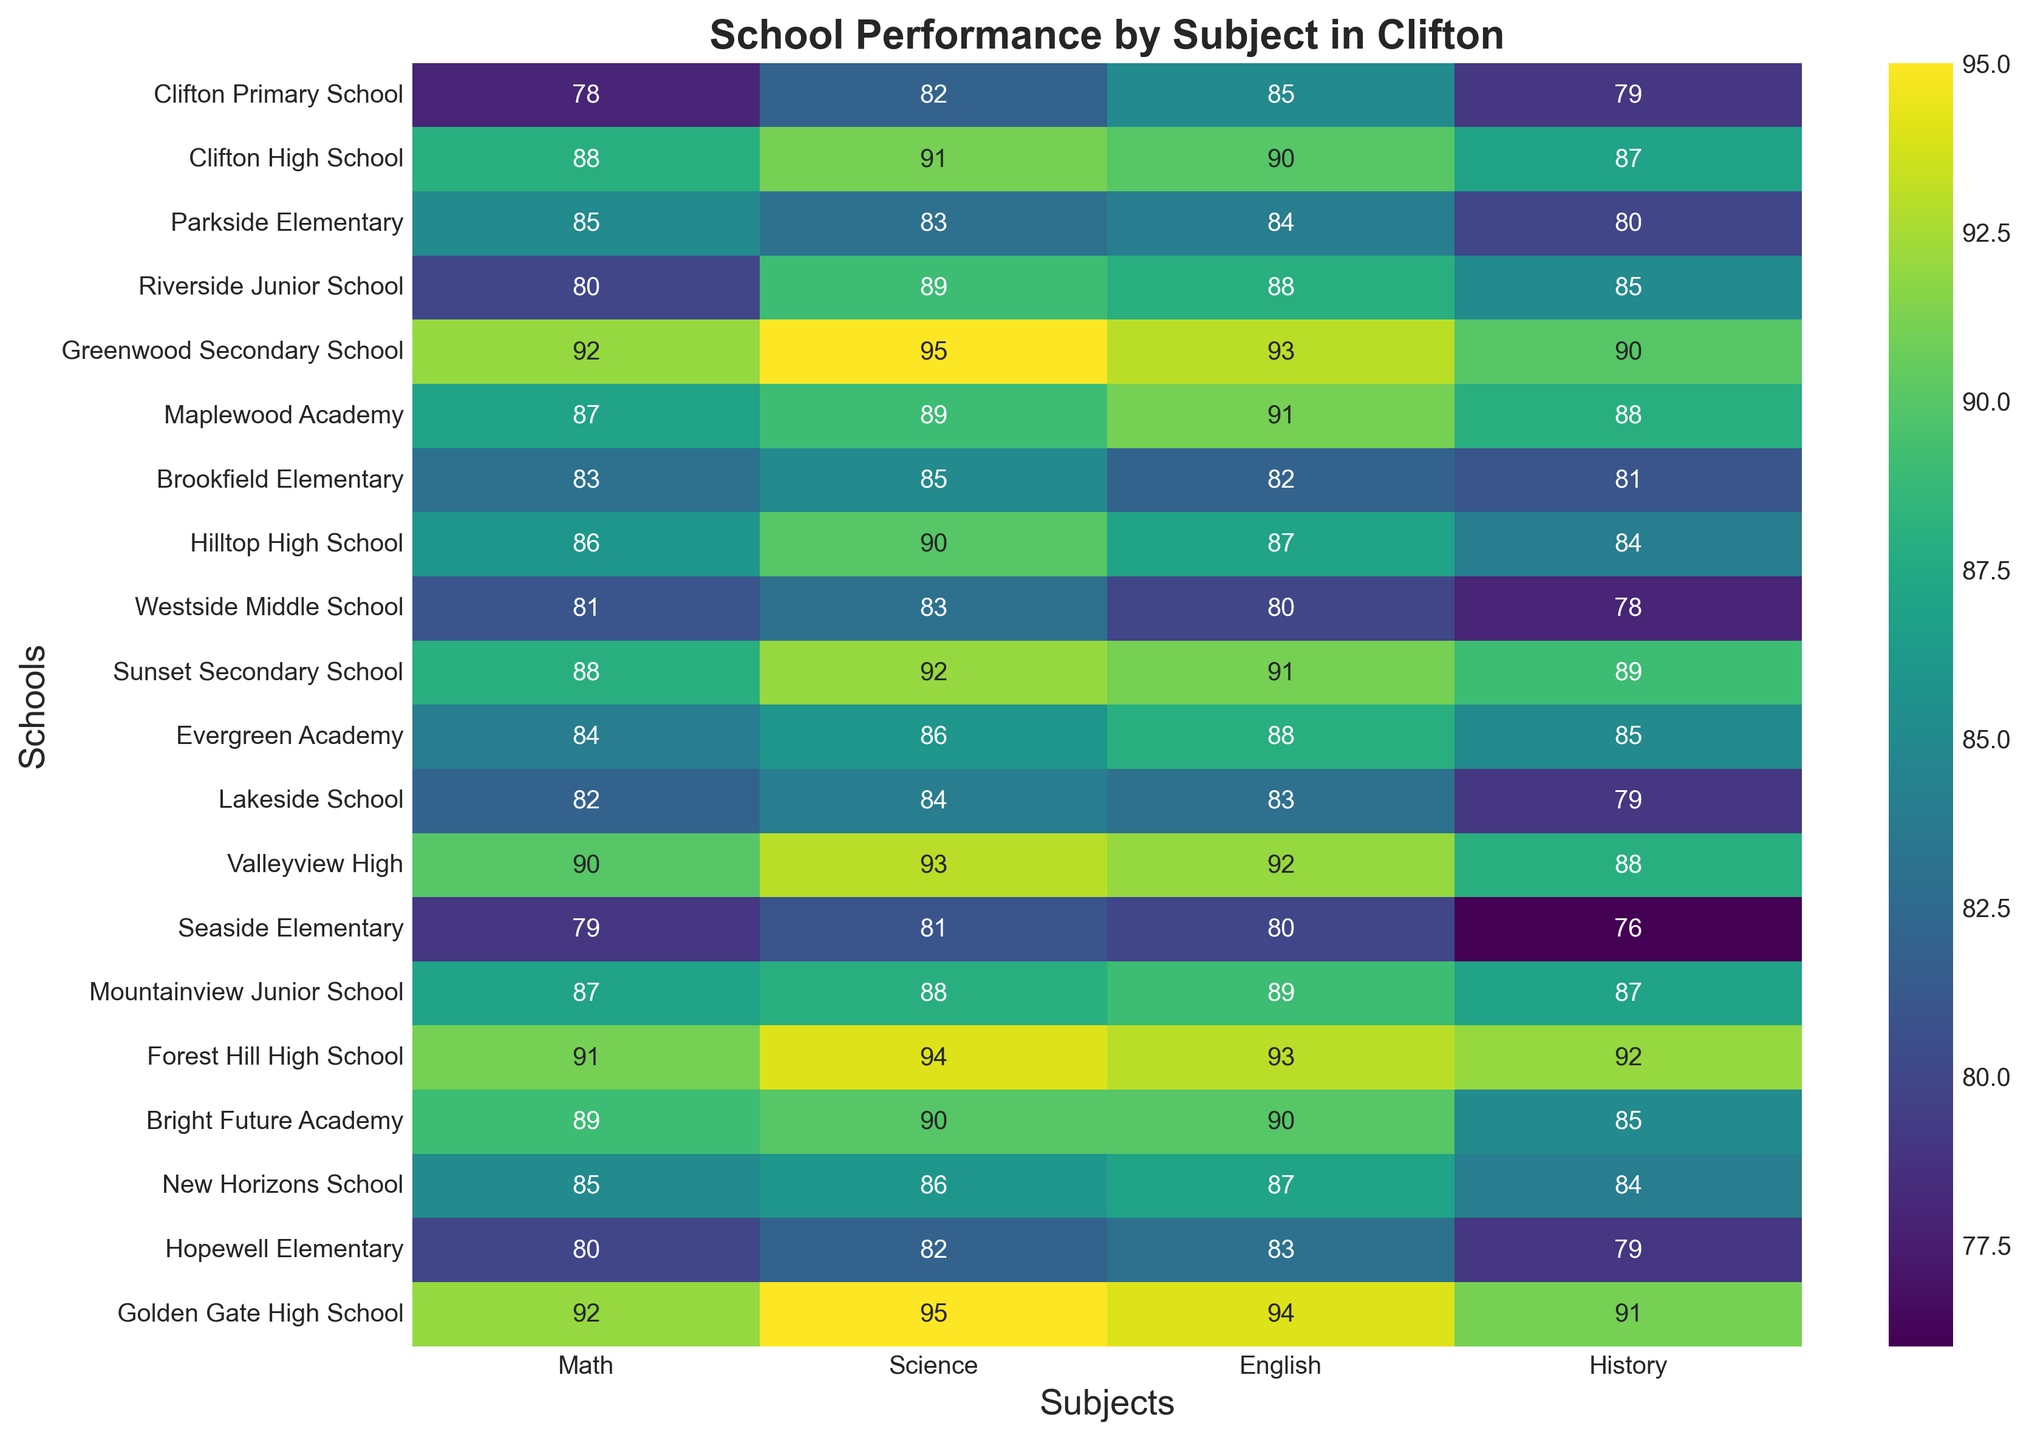Which school has the highest performance in Math? Identify the school with the highest value in the Math column. Greenwood Secondary School has the highest value of 92.
Answer: Greenwood Secondary School Compare the performance in English between Lakeside School and Hilltop High School. Which one performs better? Look at the English scores for both schools. Lakeside School has a score of 83, while Hilltop High School has a score of 87. Hilltop High School performs better.
Answer: Hilltop High School What's the difference in the Science scores between Clifton High School and Westside Middle School? Clifton High School has a Science score of 91, and Westside Middle School has a score of 83. Subtract 83 from 91 to get the difference. 91 - 83 = 8
Answer: 8 What is the average Math score for all schools? Sum up all the Math scores and divide by the number of schools. (78 + 88 + 85 + 80 + 92 + 87 + 83 + 86 + 81 + 88 + 84 + 82 + 90 + 79 + 87 + 91 + 89 + 85 + 80 + 92) / 20 = 1747 / 20 = 87.35
Answer: 87.35 Which two schools have equal scores in History? Identify schools with the same score in the History column. Clifton High School and Golden Gate High School both have a score of 91.
Answer: Clifton High School, Golden Gate High School Compare the visual attributes of the heatmap for Math scores of Seaside Elementary and Evergreen Academy. Which one has darker shading? Visually compare the shading in the Math column for both schools. Seaside Elementary has a value of 79, and Evergreen Academy has a value of 84. The lower the value, the darker the shading. Seaside Elementary has darker shading.
Answer: Seaside Elementary Which subject has the most consistent performance across all schools? Look at the heatmap and identify which subject shows the least variation in shading. English has consistently high scores across most schools, indicating consistent performance.
Answer: English Between Brookfield Elementary and Seaside Elementary, which school has a higher total score across all subjects? Sum the scores for each subject for both schools. Brookfield Elementary: 83 + 85 + 82 + 81 = 331; Seaside Elementary: 79 + 81 + 80 + 76 = 316. Brookfield Elementary has a higher total score.
Answer: Brookfield Elementary What is the range of scores for Science among all schools? Identify the highest and lowest values in the Science column and subtract the lowest from the highest score. The highest is 95 (Golden Gate High School and Greenwood Secondary School) and the lowest is 81 (Seaside Elementary). 95 - 81 = 14
Answer: 14 